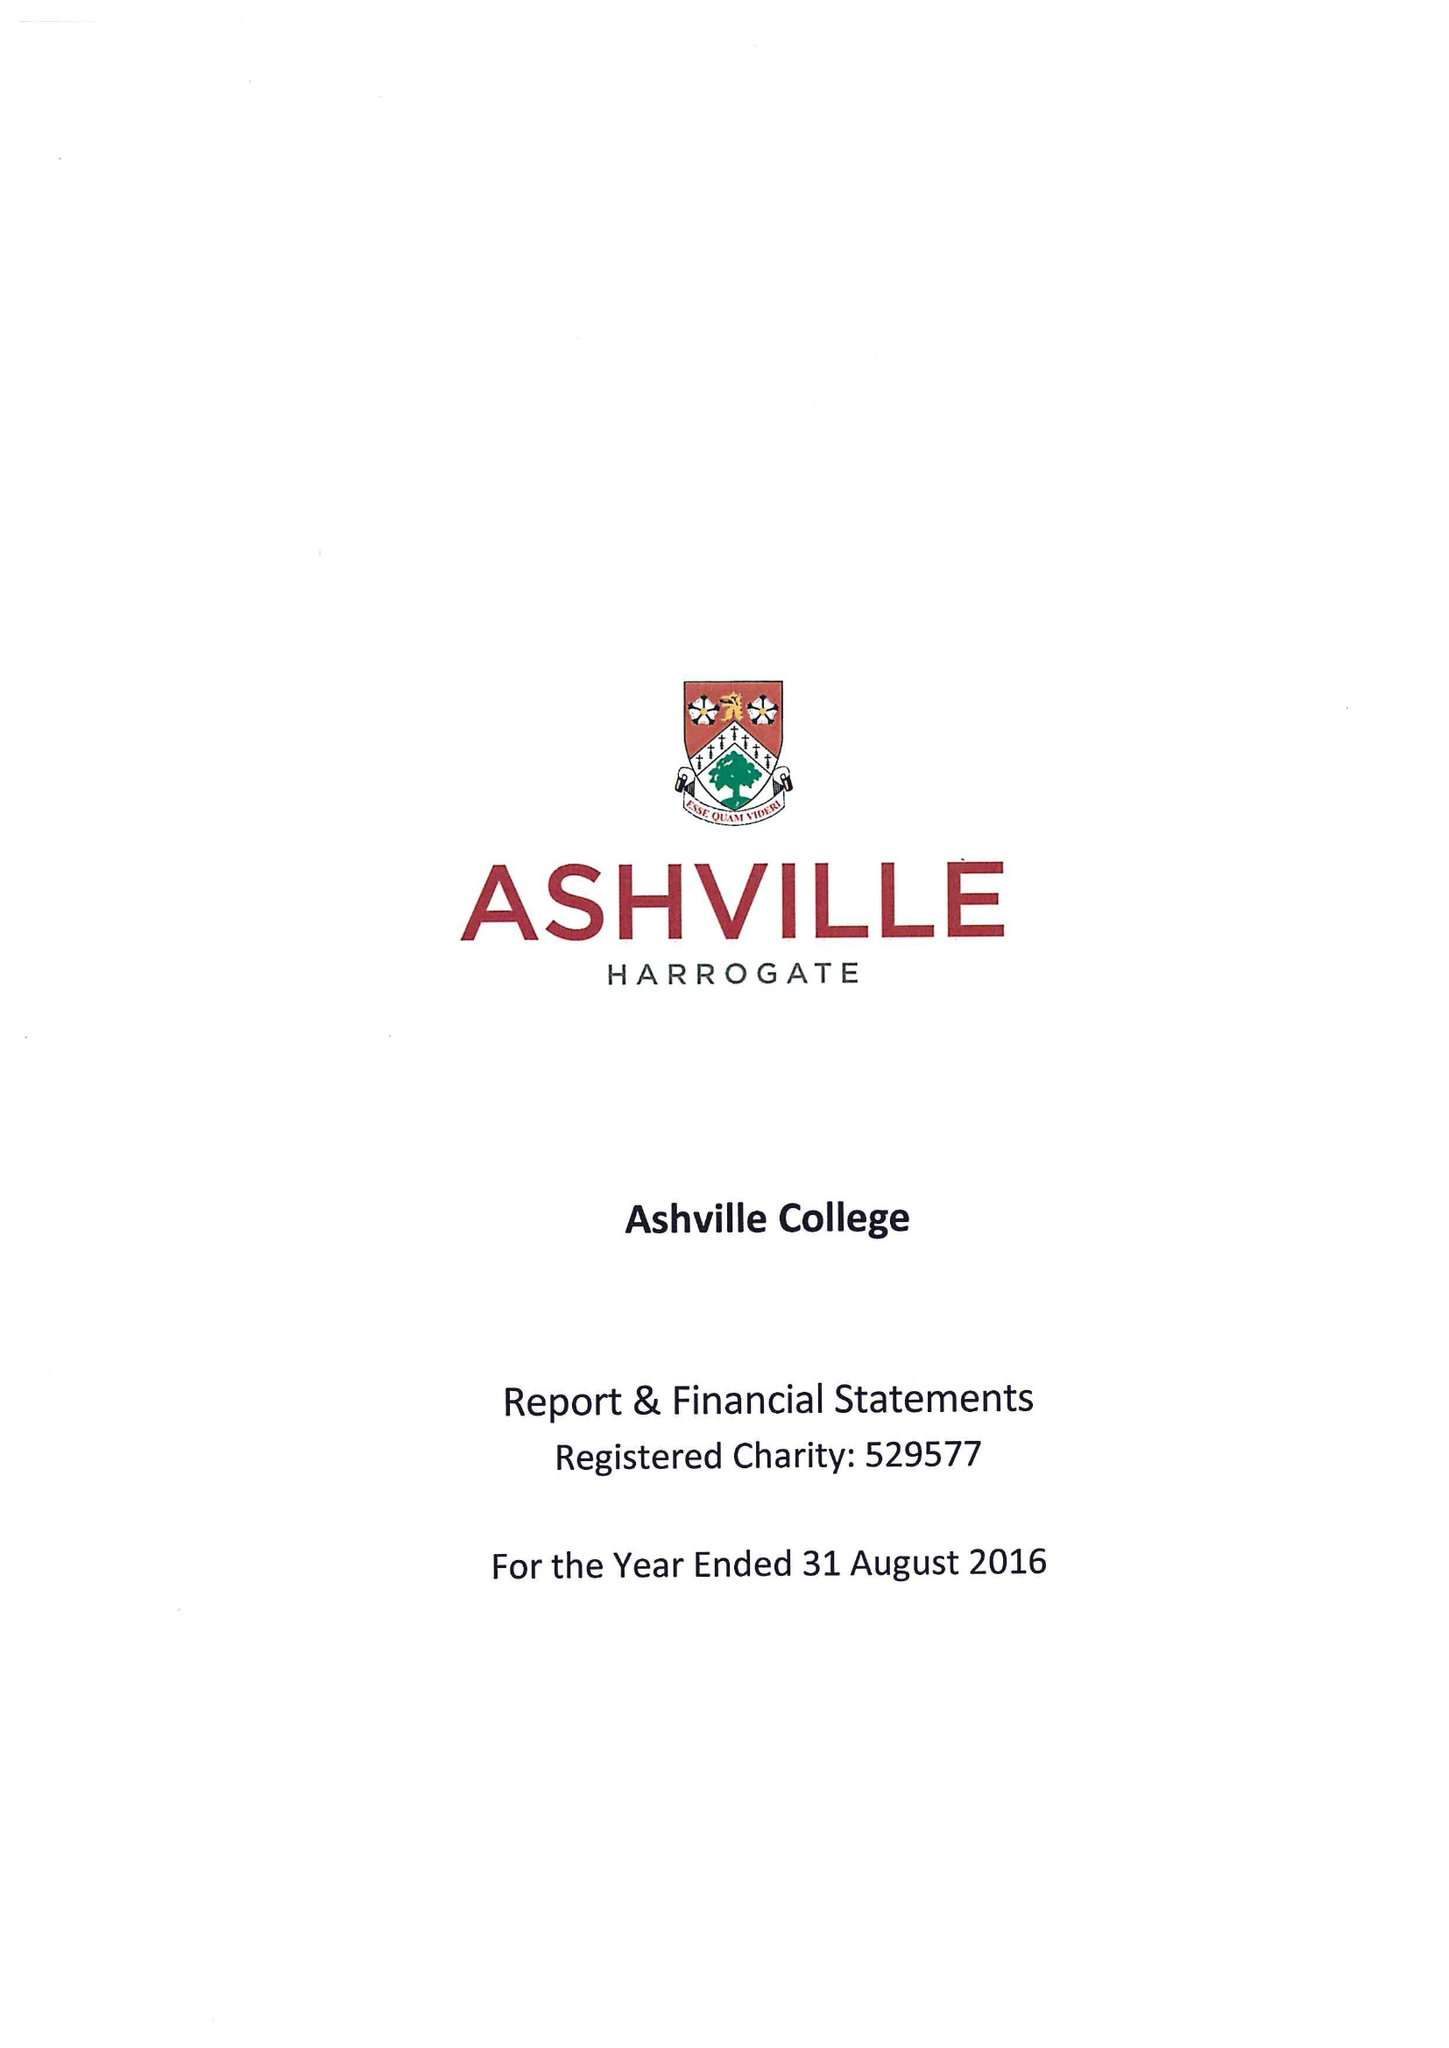What is the value for the charity_number?
Answer the question using a single word or phrase. 529577 